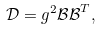<formula> <loc_0><loc_0><loc_500><loc_500>\mathcal { D } = g ^ { 2 } \mathcal { B B } ^ { T } ,</formula> 